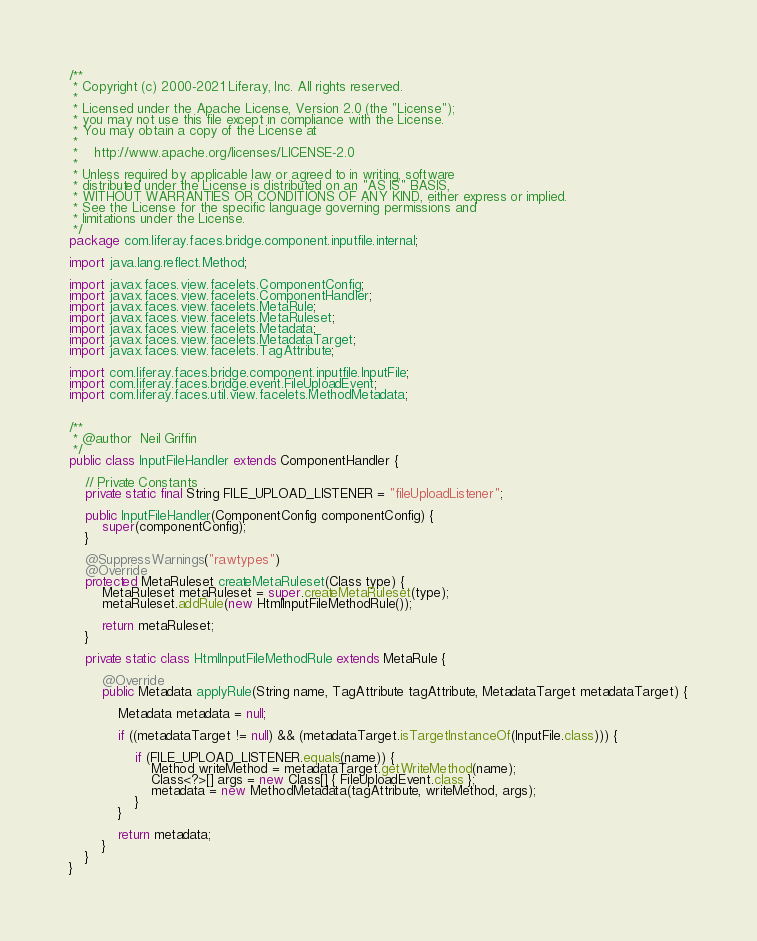Convert code to text. <code><loc_0><loc_0><loc_500><loc_500><_Java_>/**
 * Copyright (c) 2000-2021 Liferay, Inc. All rights reserved.
 *
 * Licensed under the Apache License, Version 2.0 (the "License");
 * you may not use this file except in compliance with the License.
 * You may obtain a copy of the License at
 *
 *    http://www.apache.org/licenses/LICENSE-2.0
 *
 * Unless required by applicable law or agreed to in writing, software
 * distributed under the License is distributed on an "AS IS" BASIS,
 * WITHOUT WARRANTIES OR CONDITIONS OF ANY KIND, either express or implied.
 * See the License for the specific language governing permissions and
 * limitations under the License.
 */
package com.liferay.faces.bridge.component.inputfile.internal;

import java.lang.reflect.Method;

import javax.faces.view.facelets.ComponentConfig;
import javax.faces.view.facelets.ComponentHandler;
import javax.faces.view.facelets.MetaRule;
import javax.faces.view.facelets.MetaRuleset;
import javax.faces.view.facelets.Metadata;
import javax.faces.view.facelets.MetadataTarget;
import javax.faces.view.facelets.TagAttribute;

import com.liferay.faces.bridge.component.inputfile.InputFile;
import com.liferay.faces.bridge.event.FileUploadEvent;
import com.liferay.faces.util.view.facelets.MethodMetadata;


/**
 * @author  Neil Griffin
 */
public class InputFileHandler extends ComponentHandler {

	// Private Constants
	private static final String FILE_UPLOAD_LISTENER = "fileUploadListener";

	public InputFileHandler(ComponentConfig componentConfig) {
		super(componentConfig);
	}

	@SuppressWarnings("rawtypes")
	@Override
	protected MetaRuleset createMetaRuleset(Class type) {
		MetaRuleset metaRuleset = super.createMetaRuleset(type);
		metaRuleset.addRule(new HtmlInputFileMethodRule());

		return metaRuleset;
	}

	private static class HtmlInputFileMethodRule extends MetaRule {

		@Override
		public Metadata applyRule(String name, TagAttribute tagAttribute, MetadataTarget metadataTarget) {

			Metadata metadata = null;

			if ((metadataTarget != null) && (metadataTarget.isTargetInstanceOf(InputFile.class))) {

				if (FILE_UPLOAD_LISTENER.equals(name)) {
					Method writeMethod = metadataTarget.getWriteMethod(name);
					Class<?>[] args = new Class[] { FileUploadEvent.class };
					metadata = new MethodMetadata(tagAttribute, writeMethod, args);
				}
			}

			return metadata;
		}
	}
}
</code> 